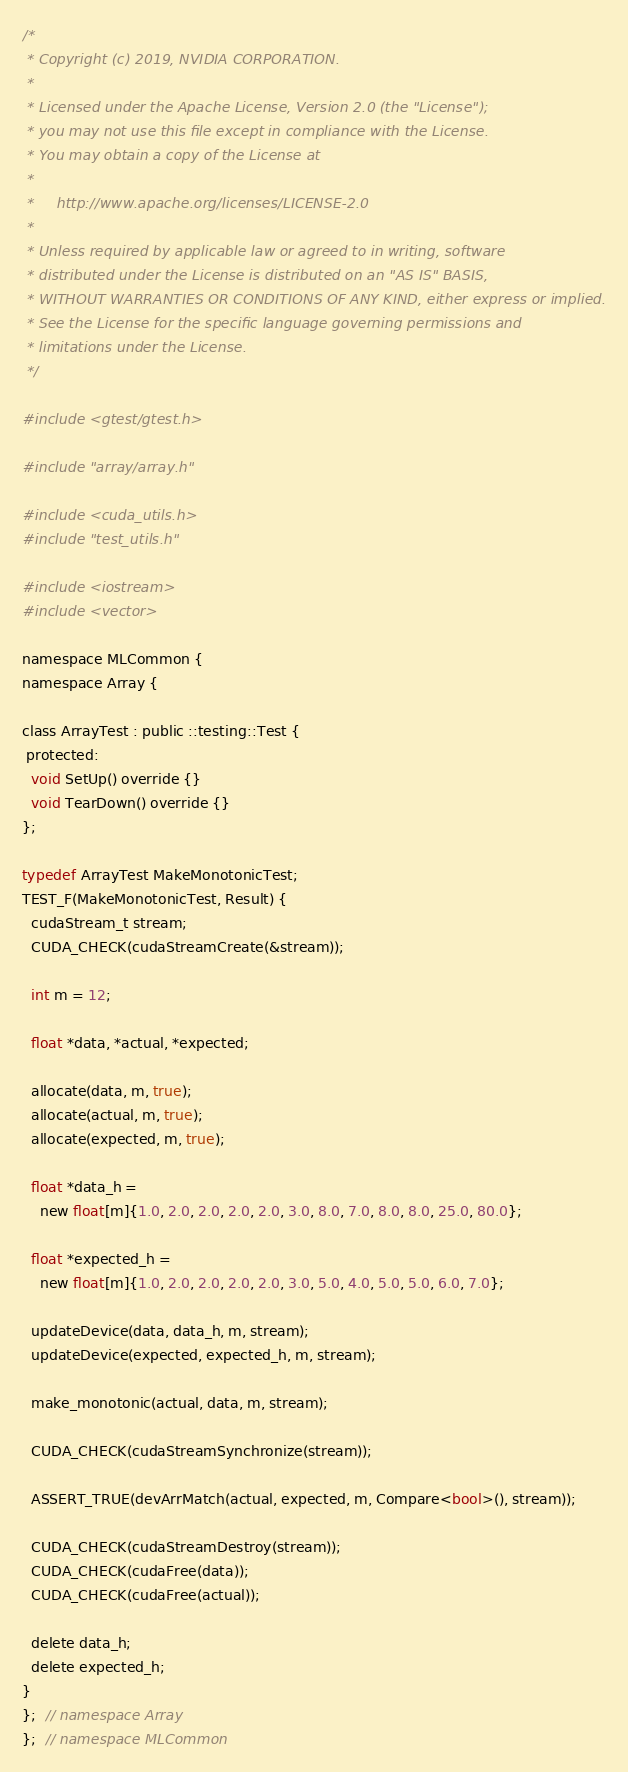Convert code to text. <code><loc_0><loc_0><loc_500><loc_500><_Cuda_>/*
 * Copyright (c) 2019, NVIDIA CORPORATION.
 *
 * Licensed under the Apache License, Version 2.0 (the "License");
 * you may not use this file except in compliance with the License.
 * You may obtain a copy of the License at
 *
 *     http://www.apache.org/licenses/LICENSE-2.0
 *
 * Unless required by applicable law or agreed to in writing, software
 * distributed under the License is distributed on an "AS IS" BASIS,
 * WITHOUT WARRANTIES OR CONDITIONS OF ANY KIND, either express or implied.
 * See the License for the specific language governing permissions and
 * limitations under the License.
 */

#include <gtest/gtest.h>

#include "array/array.h"

#include <cuda_utils.h>
#include "test_utils.h"

#include <iostream>
#include <vector>

namespace MLCommon {
namespace Array {

class ArrayTest : public ::testing::Test {
 protected:
  void SetUp() override {}
  void TearDown() override {}
};

typedef ArrayTest MakeMonotonicTest;
TEST_F(MakeMonotonicTest, Result) {
  cudaStream_t stream;
  CUDA_CHECK(cudaStreamCreate(&stream));

  int m = 12;

  float *data, *actual, *expected;

  allocate(data, m, true);
  allocate(actual, m, true);
  allocate(expected, m, true);

  float *data_h =
    new float[m]{1.0, 2.0, 2.0, 2.0, 2.0, 3.0, 8.0, 7.0, 8.0, 8.0, 25.0, 80.0};

  float *expected_h =
    new float[m]{1.0, 2.0, 2.0, 2.0, 2.0, 3.0, 5.0, 4.0, 5.0, 5.0, 6.0, 7.0};

  updateDevice(data, data_h, m, stream);
  updateDevice(expected, expected_h, m, stream);

  make_monotonic(actual, data, m, stream);

  CUDA_CHECK(cudaStreamSynchronize(stream));

  ASSERT_TRUE(devArrMatch(actual, expected, m, Compare<bool>(), stream));

  CUDA_CHECK(cudaStreamDestroy(stream));
  CUDA_CHECK(cudaFree(data));
  CUDA_CHECK(cudaFree(actual));

  delete data_h;
  delete expected_h;
}
};  // namespace Array
};  // namespace MLCommon
</code> 